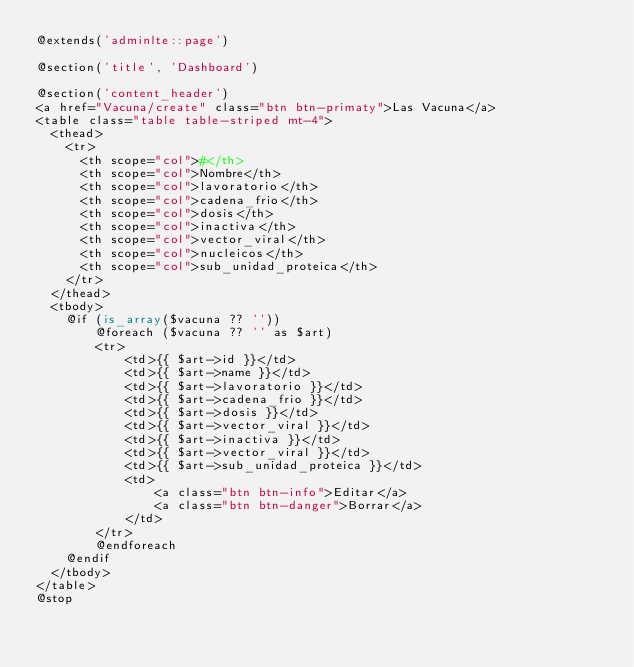Convert code to text. <code><loc_0><loc_0><loc_500><loc_500><_PHP_>@extends('adminlte::page')

@section('title', 'Dashboard')

@section('content_header')
<a href="Vacuna/create" class="btn btn-primaty">Las Vacuna</a>
<table class="table table-striped mt-4">
  <thead>
    <tr>
      <th scope="col">#</th>
      <th scope="col">Nombre</th>
      <th scope="col">lavoratorio</th>
      <th scope="col">cadena_frio</th>
      <th scope="col">dosis</th>
      <th scope="col">inactiva</th>
      <th scope="col">vector_viral</th>
      <th scope="col">nucleicos</th>
      <th scope="col">sub_unidad_proteica</th>
    </tr>
  </thead>
  <tbody>
    @if (is_array($vacuna ?? ''))
        @foreach ($vacuna ?? '' as $art)
        <tr>
            <td>{{ $art->id }}</td>
            <td>{{ $art->name }}</td>
            <td>{{ $art->lavoratorio }}</td>
            <td>{{ $art->cadena_frio }}</td>
            <td>{{ $art->dosis }}</td>
            <td>{{ $art->vector_viral }}</td>
            <td>{{ $art->inactiva }}</td>
            <td>{{ $art->vector_viral }}</td>
            <td>{{ $art->sub_unidad_proteica }}</td>
            <td>
                <a class="btn btn-info">Editar</a>
                <a class="btn btn-danger">Borrar</a>
            </td>
        </tr>
        @endforeach
    @endif 
  </tbody>
</table>
@stop
</code> 